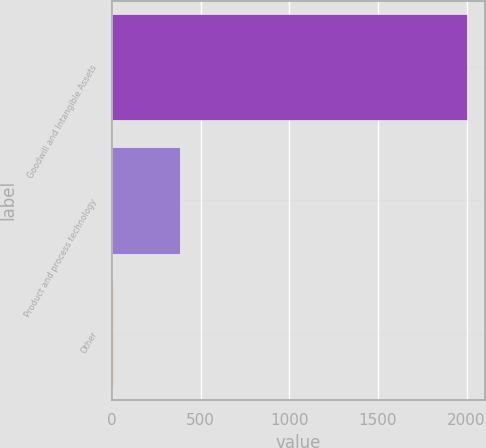Convert chart. <chart><loc_0><loc_0><loc_500><loc_500><bar_chart><fcel>Goodwill and Intangible Assets<fcel>Product and process technology<fcel>Other<nl><fcel>2005<fcel>385<fcel>5<nl></chart> 